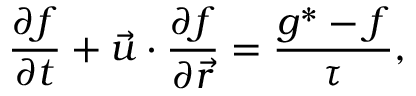<formula> <loc_0><loc_0><loc_500><loc_500>\frac { { \partial { f } } } { \partial t } + { \vec { u } } \cdot \frac { { \partial { f } } } { { \partial { \vec { r } } } } = \frac { { g } ^ { \ast } - { f } } { \tau } ,</formula> 